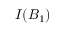Convert formula to latex. <formula><loc_0><loc_0><loc_500><loc_500>I ( B _ { 1 } )</formula> 